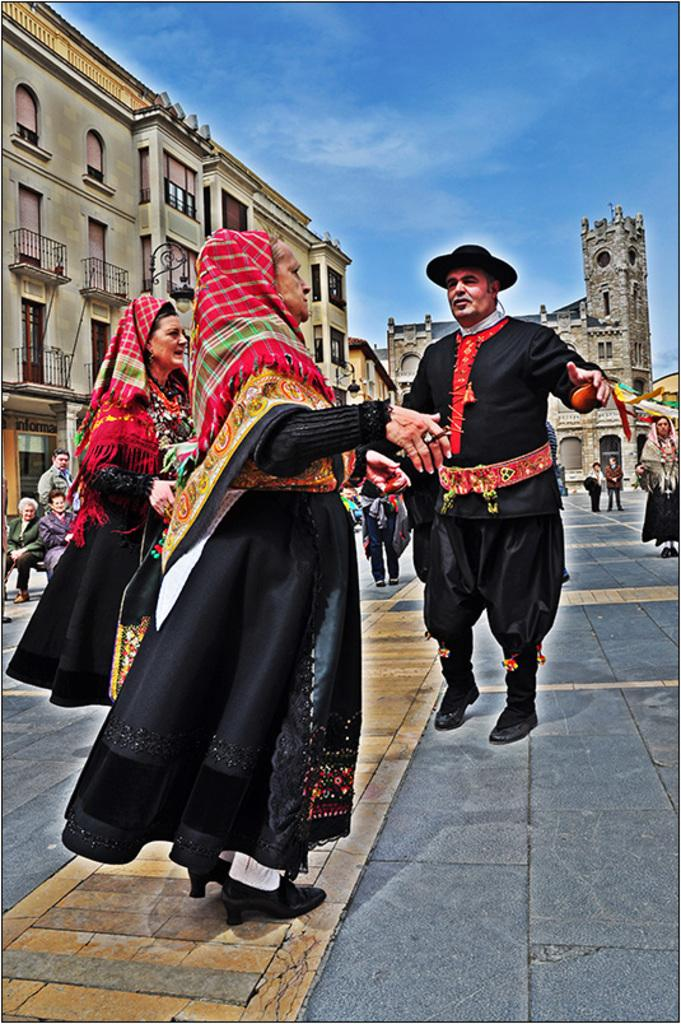Who or what is present in the image? There are people in the image. What structures can be seen in the image? There are buildings in the image. What architectural features are visible in the image? There are windows and railings in the image. What part of the natural environment is visible in the image? The sky is visible in the image. Where is the rabbit performing its act in the image? There is no rabbit or act present in the image. 